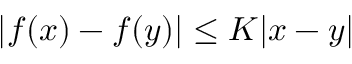Convert formula to latex. <formula><loc_0><loc_0><loc_500><loc_500>| f ( x ) - f ( y ) | \leq K | x - y |</formula> 